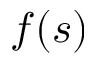Convert formula to latex. <formula><loc_0><loc_0><loc_500><loc_500>f ( s )</formula> 